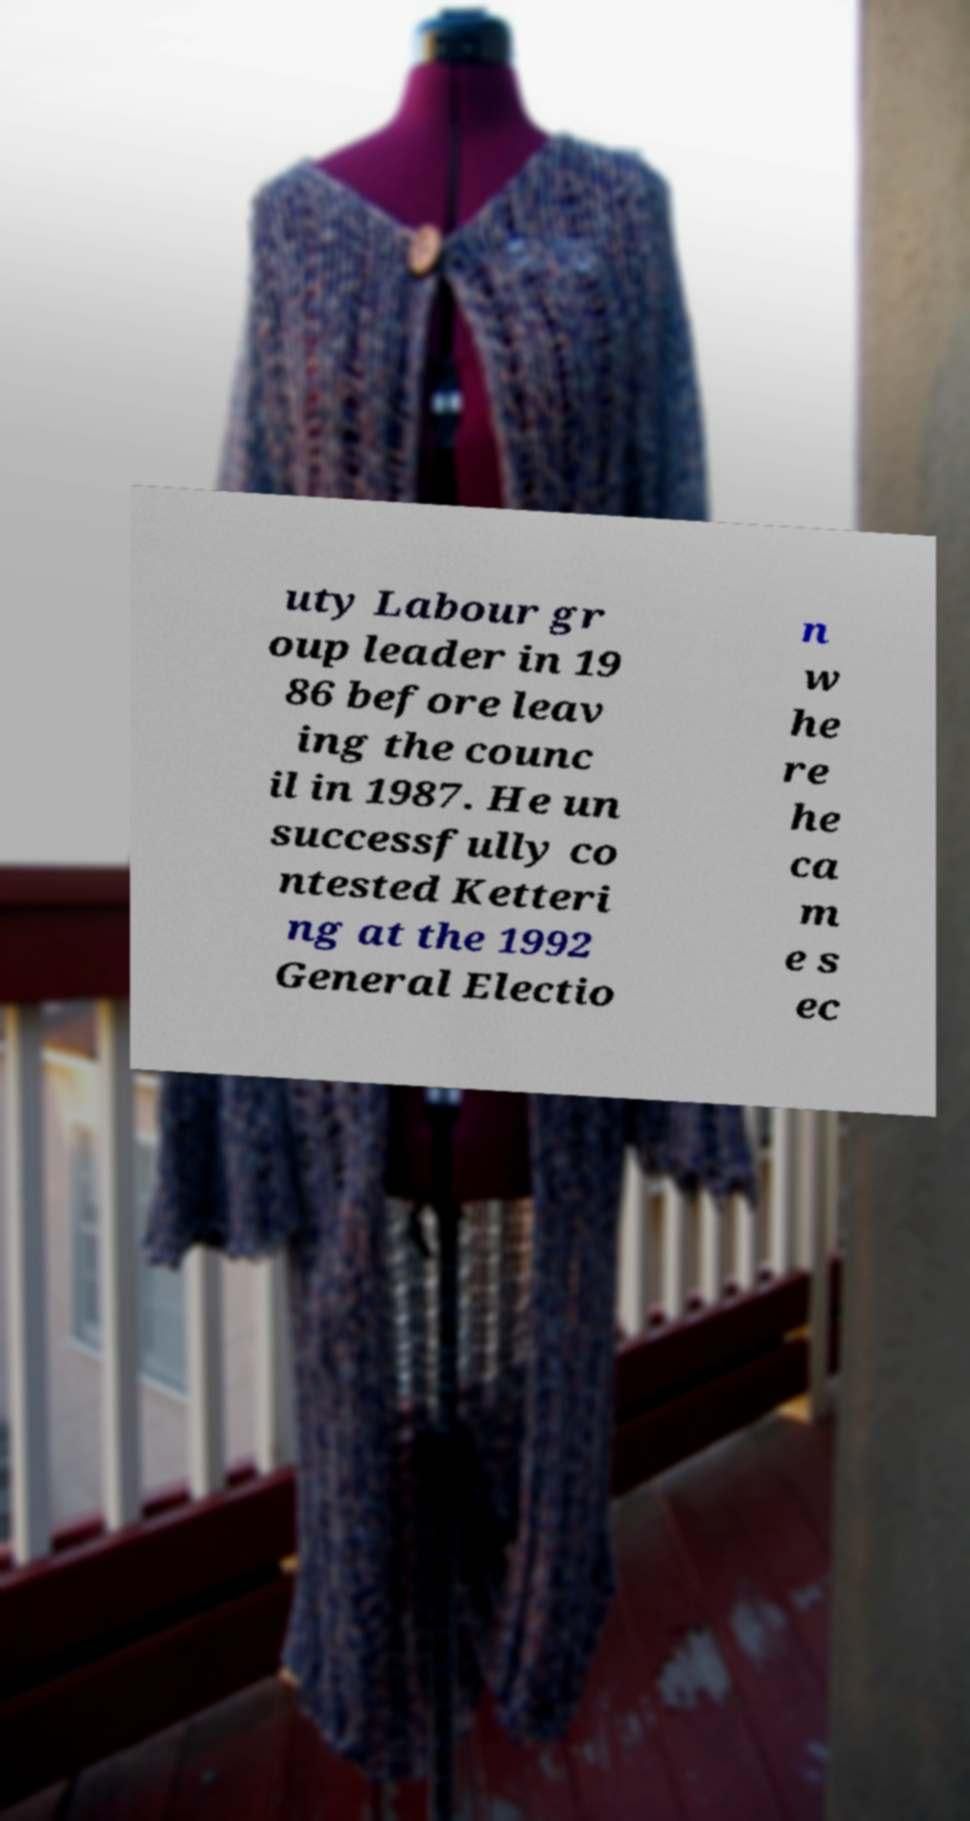There's text embedded in this image that I need extracted. Can you transcribe it verbatim? uty Labour gr oup leader in 19 86 before leav ing the counc il in 1987. He un successfully co ntested Ketteri ng at the 1992 General Electio n w he re he ca m e s ec 